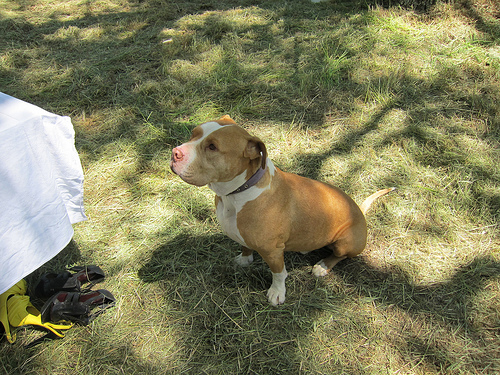<image>
Can you confirm if the shoes is to the left of the collar? Yes. From this viewpoint, the shoes is positioned to the left side relative to the collar. 